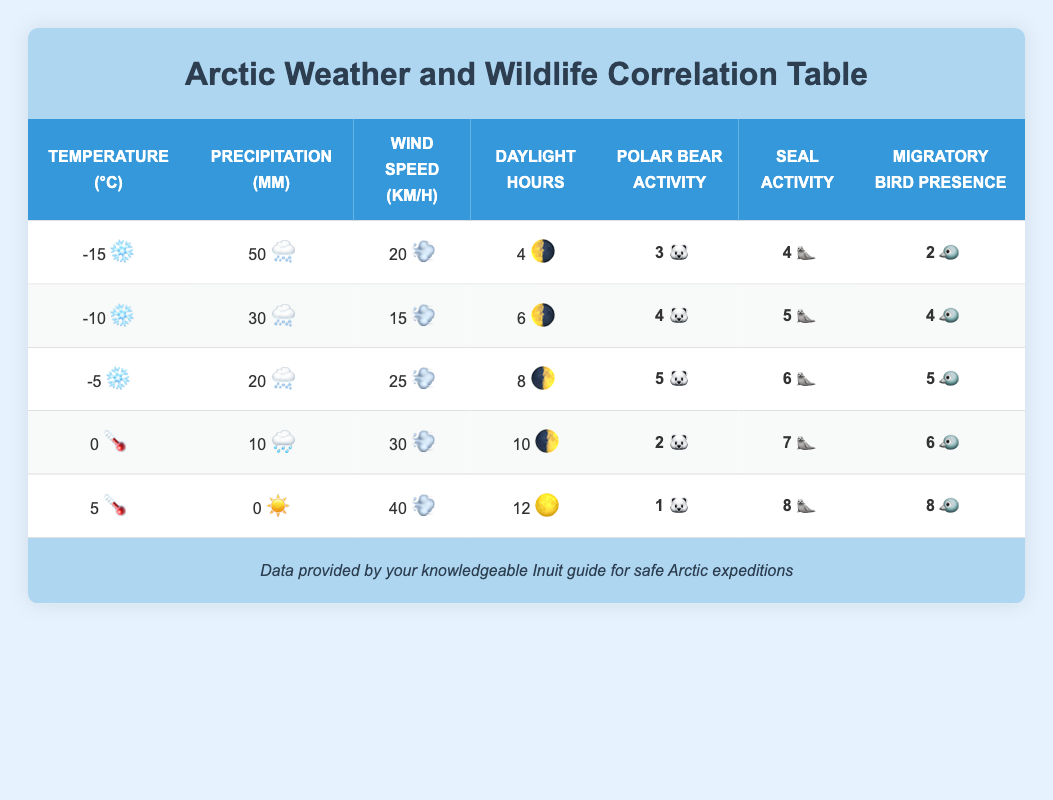What is the activity level of polar bears at -10 degrees Celsius? In the row corresponding to -10 degrees Celsius, the Polar Bear Activity Level is listed as 4.
Answer: 4 What is the maximum seal activity level recorded in the table? By examining the Seal Activity Levels across all rows, the maximum value is 8, found at 5 degrees Celsius.
Answer: 8 Is there a positive correlation between temperature and migratory bird presence? Observing the data, as the temperature increases from -15 to 5 degrees Celsius, the Migratory Bird Presence also rises from 2 to 8. This indicates a positive correlation.
Answer: Yes What is the average wind speed across all the weather patterns listed? To find the average wind speed, sum the wind speeds (20 + 15 + 25 + 30 + 40 = 130) and divide by the number of entries (5), resulting in 130/5 = 26.
Answer: 26 At what temperature do polar bears have their lowest activity level? Looking at the Polar Bear Activity Levels, the lowest is 1, which occurs at 5 degrees Celsius.
Answer: 5 degrees Celsius How does the level of migratory birds change from -15 to 5 degrees Celsius? The Migratory Bird Presence starts at 2 at -15 degrees Celsius and increases to 8 at 5 degrees Celsius, showing a rise of 6 over this range.
Answer: It rises by 6 Is there a condition where the seal activity level is equal to or greater than 6? Yes, during the temperature readings of -5, 0, and 5 degrees Celsius, the Seal Activity Levels are 6, 7, and 8, respectively, indicating instances where the level is greater than or equal to 6.
Answer: Yes What is the difference in daylight hours between the coldest and warmest temperatures? The coldest temperature is -15 degrees Celsius with 4 daylight hours, and the warmest is 5 degrees Celsius with 12 daylight hours. The difference is 12 - 4 = 8 hours.
Answer: 8 hours What pattern do you observe between precipitation and polar bear activity levels? As the amount of precipitation decreases from 50 mm at -15 degrees Celsius to 0 mm at 5 degrees Celsius, the Polar Bear Activity Level generally decreases, suggesting a potential inverse relationship.
Answer: Decreases 